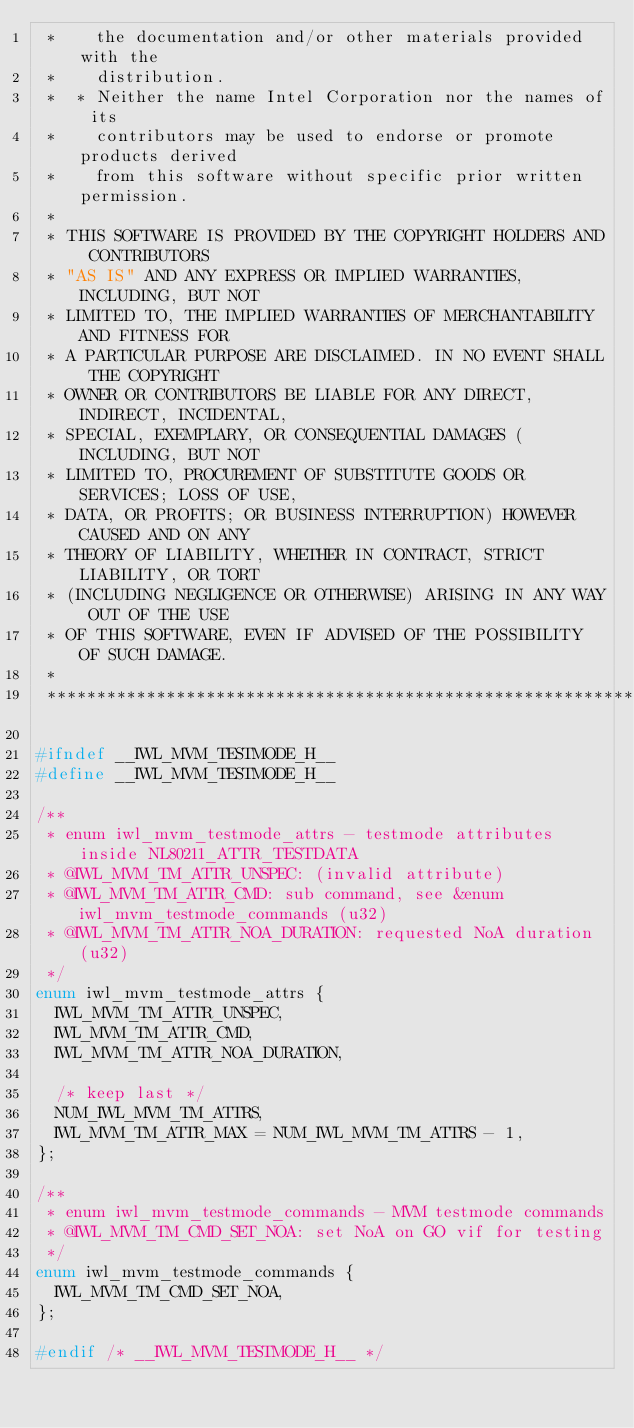Convert code to text. <code><loc_0><loc_0><loc_500><loc_500><_C_> *    the documentation and/or other materials provided with the
 *    distribution.
 *  * Neither the name Intel Corporation nor the names of its
 *    contributors may be used to endorse or promote products derived
 *    from this software without specific prior written permission.
 *
 * THIS SOFTWARE IS PROVIDED BY THE COPYRIGHT HOLDERS AND CONTRIBUTORS
 * "AS IS" AND ANY EXPRESS OR IMPLIED WARRANTIES, INCLUDING, BUT NOT
 * LIMITED TO, THE IMPLIED WARRANTIES OF MERCHANTABILITY AND FITNESS FOR
 * A PARTICULAR PURPOSE ARE DISCLAIMED. IN NO EVENT SHALL THE COPYRIGHT
 * OWNER OR CONTRIBUTORS BE LIABLE FOR ANY DIRECT, INDIRECT, INCIDENTAL,
 * SPECIAL, EXEMPLARY, OR CONSEQUENTIAL DAMAGES (INCLUDING, BUT NOT
 * LIMITED TO, PROCUREMENT OF SUBSTITUTE GOODS OR SERVICES; LOSS OF USE,
 * DATA, OR PROFITS; OR BUSINESS INTERRUPTION) HOWEVER CAUSED AND ON ANY
 * THEORY OF LIABILITY, WHETHER IN CONTRACT, STRICT LIABILITY, OR TORT
 * (INCLUDING NEGLIGENCE OR OTHERWISE) ARISING IN ANY WAY OUT OF THE USE
 * OF THIS SOFTWARE, EVEN IF ADVISED OF THE POSSIBILITY OF SUCH DAMAGE.
 *
 *****************************************************************************/

#ifndef __IWL_MVM_TESTMODE_H__
#define __IWL_MVM_TESTMODE_H__

/**
 * enum iwl_mvm_testmode_attrs - testmode attributes inside NL80211_ATTR_TESTDATA
 * @IWL_MVM_TM_ATTR_UNSPEC: (invalid attribute)
 * @IWL_MVM_TM_ATTR_CMD: sub command, see &enum iwl_mvm_testmode_commands (u32)
 * @IWL_MVM_TM_ATTR_NOA_DURATION: requested NoA duration (u32)
 */
enum iwl_mvm_testmode_attrs {
	IWL_MVM_TM_ATTR_UNSPEC,
	IWL_MVM_TM_ATTR_CMD,
	IWL_MVM_TM_ATTR_NOA_DURATION,

	/* keep last */
	NUM_IWL_MVM_TM_ATTRS,
	IWL_MVM_TM_ATTR_MAX = NUM_IWL_MVM_TM_ATTRS - 1,
};

/**
 * enum iwl_mvm_testmode_commands - MVM testmode commands
 * @IWL_MVM_TM_CMD_SET_NOA: set NoA on GO vif for testing
 */
enum iwl_mvm_testmode_commands {
	IWL_MVM_TM_CMD_SET_NOA,
};

#endif /* __IWL_MVM_TESTMODE_H__ */
</code> 